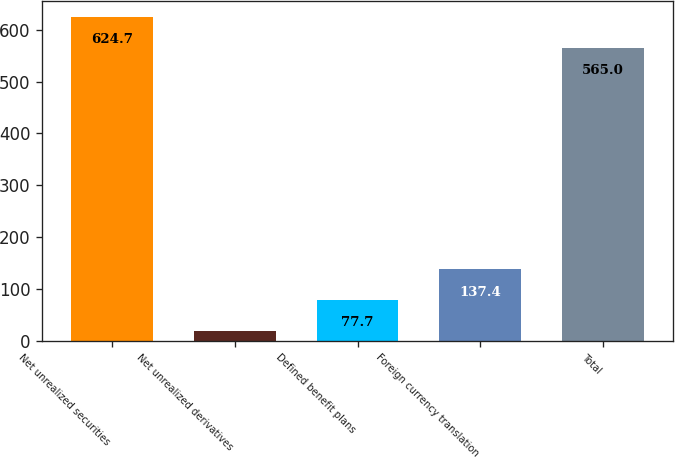<chart> <loc_0><loc_0><loc_500><loc_500><bar_chart><fcel>Net unrealized securities<fcel>Net unrealized derivatives<fcel>Defined benefit plans<fcel>Foreign currency translation<fcel>Total<nl><fcel>624.7<fcel>18<fcel>77.7<fcel>137.4<fcel>565<nl></chart> 